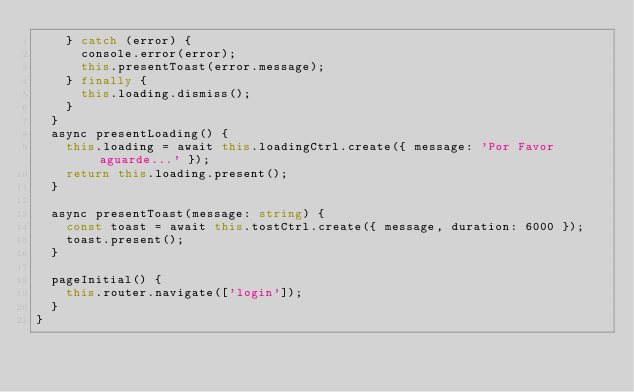Convert code to text. <code><loc_0><loc_0><loc_500><loc_500><_TypeScript_>    } catch (error) {
      console.error(error);
      this.presentToast(error.message);
    } finally {
      this.loading.dismiss();
    }
  }
  async presentLoading() {
    this.loading = await this.loadingCtrl.create({ message: 'Por Favor aguarde...' });
    return this.loading.present();
  }

  async presentToast(message: string) {
    const toast = await this.tostCtrl.create({ message, duration: 6000 });
    toast.present();
  }

  pageInitial() {
    this.router.navigate(['login']);
  }
}
</code> 